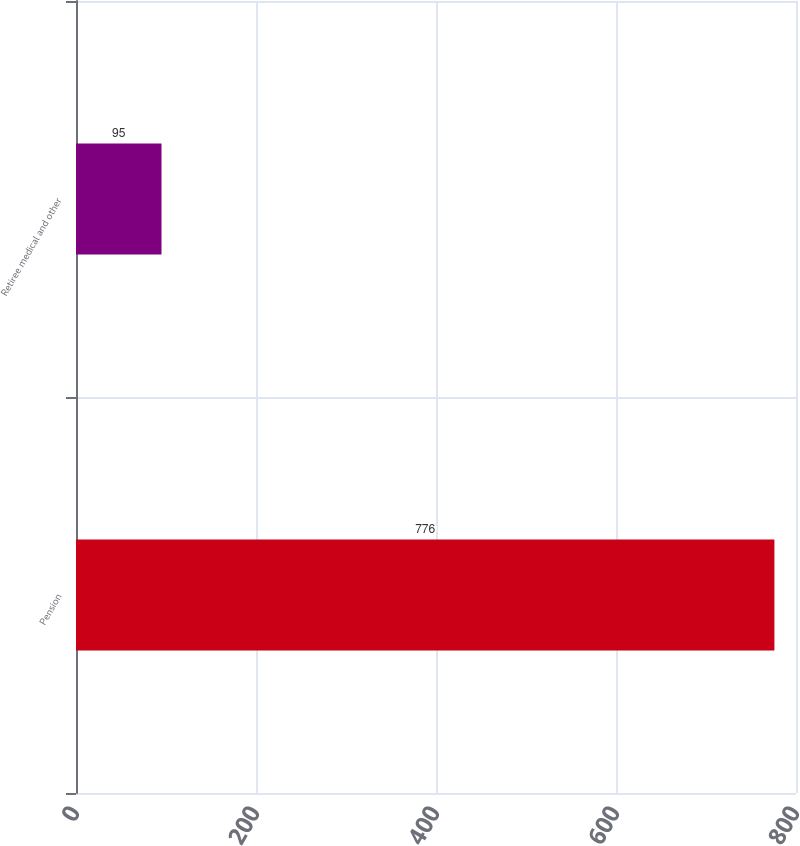Convert chart. <chart><loc_0><loc_0><loc_500><loc_500><bar_chart><fcel>Pension<fcel>Retiree medical and other<nl><fcel>776<fcel>95<nl></chart> 